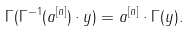<formula> <loc_0><loc_0><loc_500><loc_500>\Gamma ( \Gamma ^ { - 1 } ( a ^ { [ n ] } ) \cdot y ) = a ^ { [ n ] } \cdot \Gamma ( y ) .</formula> 